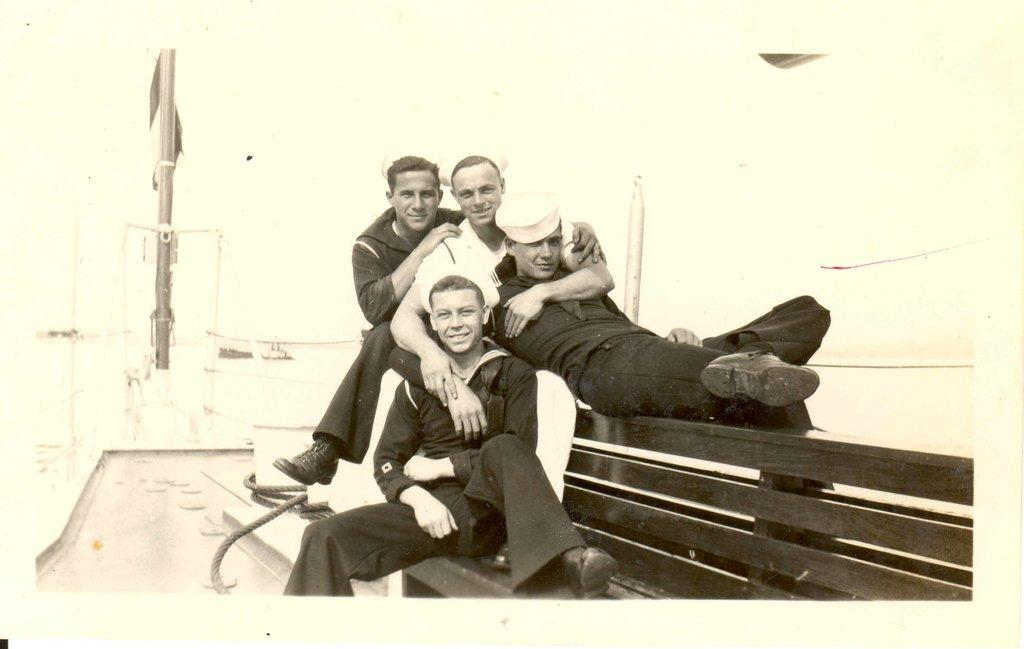What type of picture is the image? The image is an old black and white picture. How many people are sitting on the bench in the image? There are three people sitting on a bench in the image. What is the position of the man in the image? A man is lying down in the image. What objects can be seen in the image related to ropes and poles? There is a rope and a pole visible in the image. Can you describe any other objects in the image? There are other unspecified objects visible in the image. What color is the sweater worn by the man in the image? There is no sweater visible in the image, as it is an old black and white picture. Can you tell me how many mint leaves are on the bench in the image? There are no mint leaves present in the image. 